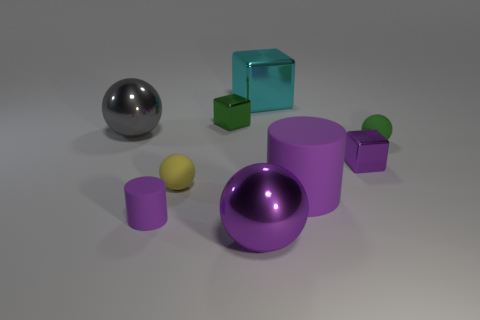What is the shape of the large gray metallic object that is in front of the cyan block behind the small green metal cube?
Make the answer very short. Sphere. There is a shiny ball that is to the right of the gray metallic thing; does it have the same color as the tiny cylinder?
Provide a succinct answer. Yes. The object that is both to the left of the tiny purple metal cube and right of the cyan block is what color?
Your response must be concise. Purple. Are there any big purple spheres that have the same material as the cyan block?
Your response must be concise. Yes. How big is the cyan shiny object?
Keep it short and to the point. Large. What size is the purple block behind the tiny purple thing that is left of the big purple sphere?
Provide a short and direct response. Small. There is a gray thing that is the same shape as the small yellow object; what material is it?
Give a very brief answer. Metal. How many yellow rubber spheres are there?
Keep it short and to the point. 1. There is a cylinder that is on the right side of the yellow matte sphere that is behind the purple matte cylinder that is right of the yellow sphere; what is its color?
Provide a short and direct response. Purple. Is the number of large cyan blocks less than the number of large green matte things?
Offer a very short reply. No. 